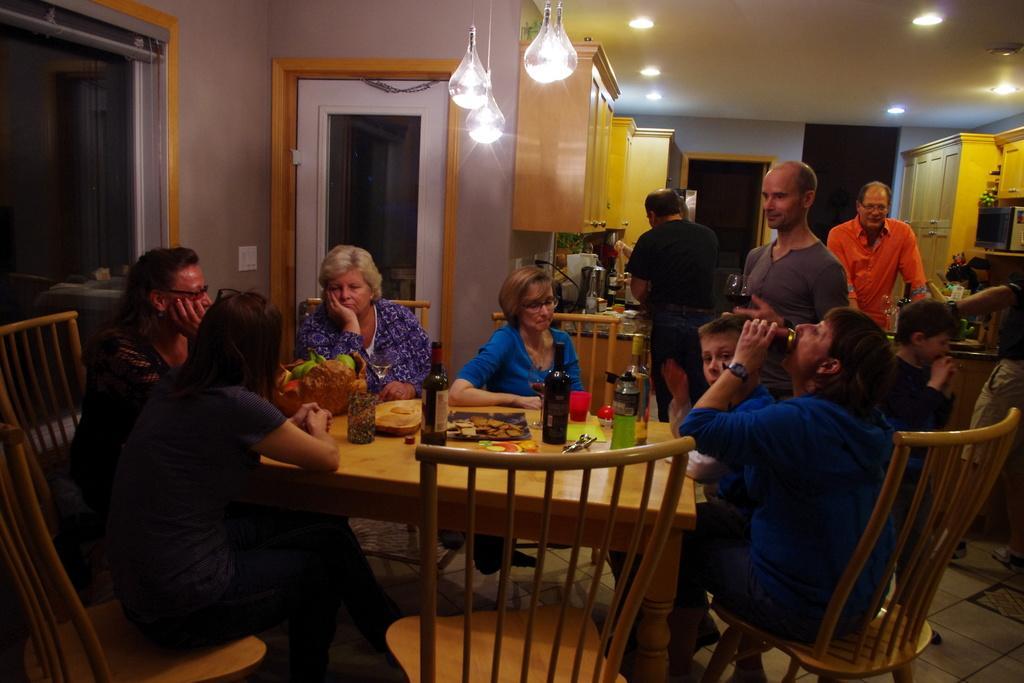How would you summarize this image in a sentence or two? Here we can see a group of people are sitting on the chair, and in front here is the table and wine bottle on it and some other objects on it, and at back here is the table and many objects on it, and her a person is standing on the floor, and at above here are the lights and here is the door. 